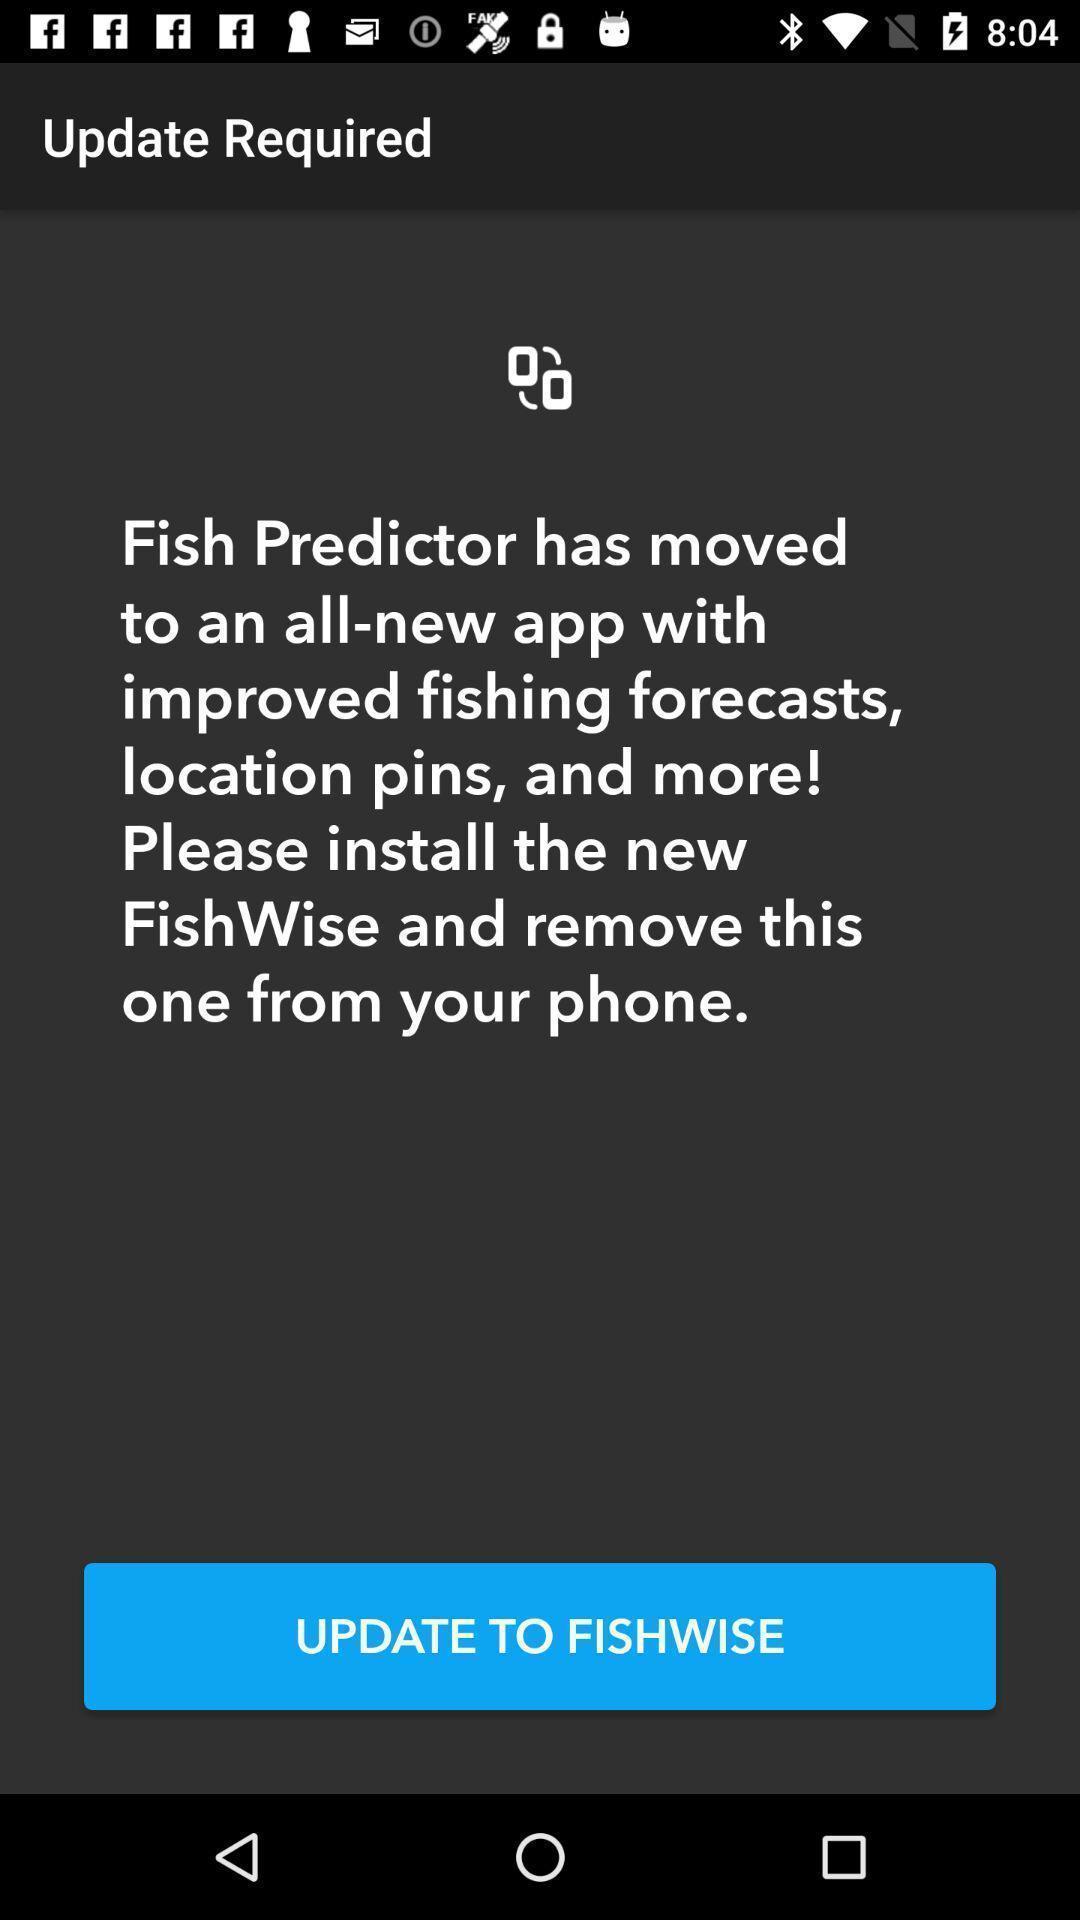Describe the content in this image. Updation page. 